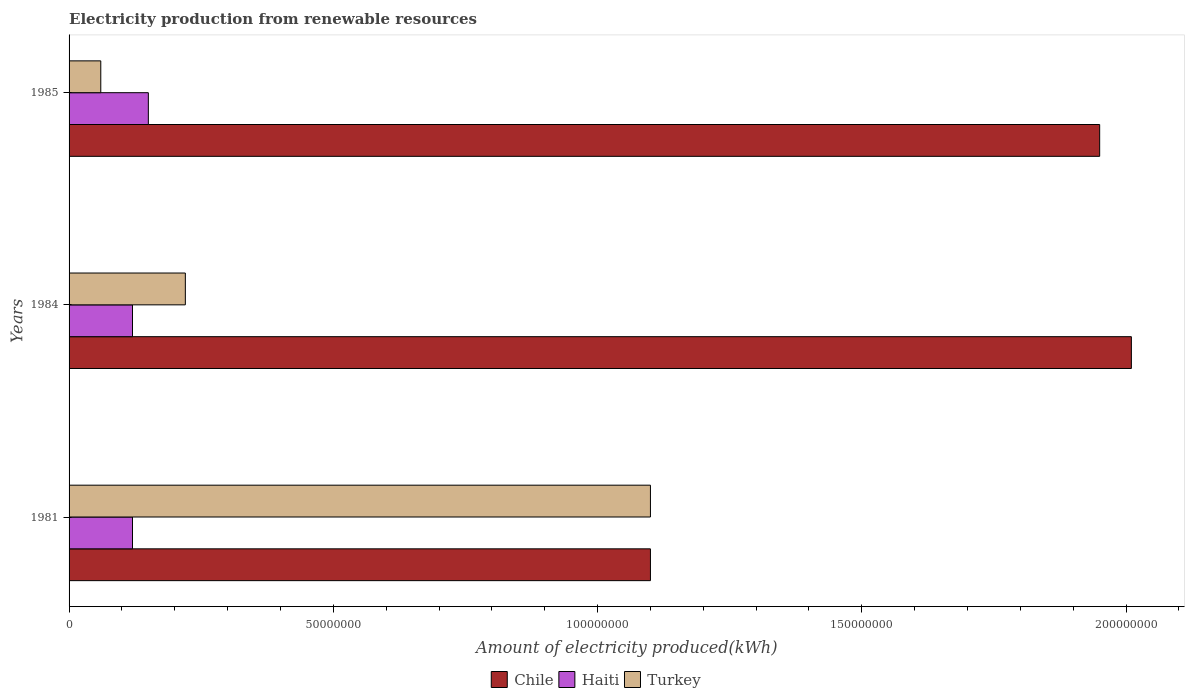Are the number of bars on each tick of the Y-axis equal?
Your answer should be very brief. Yes. How many bars are there on the 2nd tick from the bottom?
Your response must be concise. 3. In how many cases, is the number of bars for a given year not equal to the number of legend labels?
Keep it short and to the point. 0. What is the amount of electricity produced in Turkey in 1985?
Your response must be concise. 6.00e+06. Across all years, what is the maximum amount of electricity produced in Haiti?
Keep it short and to the point. 1.50e+07. Across all years, what is the minimum amount of electricity produced in Chile?
Provide a short and direct response. 1.10e+08. In which year was the amount of electricity produced in Haiti minimum?
Your response must be concise. 1981. What is the total amount of electricity produced in Haiti in the graph?
Your response must be concise. 3.90e+07. What is the difference between the amount of electricity produced in Haiti in 1981 and the amount of electricity produced in Turkey in 1985?
Your answer should be very brief. 6.00e+06. What is the average amount of electricity produced in Haiti per year?
Your answer should be very brief. 1.30e+07. In the year 1981, what is the difference between the amount of electricity produced in Haiti and amount of electricity produced in Chile?
Give a very brief answer. -9.80e+07. In how many years, is the amount of electricity produced in Chile greater than 20000000 kWh?
Provide a short and direct response. 3. What is the ratio of the amount of electricity produced in Turkey in 1984 to that in 1985?
Your answer should be compact. 3.67. What is the difference between the highest and the lowest amount of electricity produced in Haiti?
Your answer should be very brief. 3.00e+06. In how many years, is the amount of electricity produced in Chile greater than the average amount of electricity produced in Chile taken over all years?
Provide a short and direct response. 2. Is the sum of the amount of electricity produced in Haiti in 1981 and 1984 greater than the maximum amount of electricity produced in Chile across all years?
Ensure brevity in your answer.  No. What does the 2nd bar from the top in 1981 represents?
Offer a terse response. Haiti. What does the 2nd bar from the bottom in 1981 represents?
Offer a very short reply. Haiti. Is it the case that in every year, the sum of the amount of electricity produced in Turkey and amount of electricity produced in Chile is greater than the amount of electricity produced in Haiti?
Provide a succinct answer. Yes. How many bars are there?
Your answer should be compact. 9. What is the difference between two consecutive major ticks on the X-axis?
Your response must be concise. 5.00e+07. Does the graph contain any zero values?
Keep it short and to the point. No. Where does the legend appear in the graph?
Your answer should be compact. Bottom center. How many legend labels are there?
Give a very brief answer. 3. How are the legend labels stacked?
Provide a succinct answer. Horizontal. What is the title of the graph?
Make the answer very short. Electricity production from renewable resources. Does "Ukraine" appear as one of the legend labels in the graph?
Give a very brief answer. No. What is the label or title of the X-axis?
Provide a short and direct response. Amount of electricity produced(kWh). What is the Amount of electricity produced(kWh) of Chile in 1981?
Give a very brief answer. 1.10e+08. What is the Amount of electricity produced(kWh) of Turkey in 1981?
Offer a terse response. 1.10e+08. What is the Amount of electricity produced(kWh) in Chile in 1984?
Your answer should be very brief. 2.01e+08. What is the Amount of electricity produced(kWh) of Haiti in 1984?
Your answer should be very brief. 1.20e+07. What is the Amount of electricity produced(kWh) of Turkey in 1984?
Keep it short and to the point. 2.20e+07. What is the Amount of electricity produced(kWh) of Chile in 1985?
Make the answer very short. 1.95e+08. What is the Amount of electricity produced(kWh) in Haiti in 1985?
Offer a terse response. 1.50e+07. Across all years, what is the maximum Amount of electricity produced(kWh) of Chile?
Ensure brevity in your answer.  2.01e+08. Across all years, what is the maximum Amount of electricity produced(kWh) in Haiti?
Ensure brevity in your answer.  1.50e+07. Across all years, what is the maximum Amount of electricity produced(kWh) in Turkey?
Offer a terse response. 1.10e+08. Across all years, what is the minimum Amount of electricity produced(kWh) in Chile?
Your answer should be very brief. 1.10e+08. Across all years, what is the minimum Amount of electricity produced(kWh) of Turkey?
Provide a succinct answer. 6.00e+06. What is the total Amount of electricity produced(kWh) in Chile in the graph?
Your answer should be very brief. 5.06e+08. What is the total Amount of electricity produced(kWh) of Haiti in the graph?
Ensure brevity in your answer.  3.90e+07. What is the total Amount of electricity produced(kWh) in Turkey in the graph?
Ensure brevity in your answer.  1.38e+08. What is the difference between the Amount of electricity produced(kWh) in Chile in 1981 and that in 1984?
Your response must be concise. -9.10e+07. What is the difference between the Amount of electricity produced(kWh) of Haiti in 1981 and that in 1984?
Your answer should be compact. 0. What is the difference between the Amount of electricity produced(kWh) of Turkey in 1981 and that in 1984?
Your response must be concise. 8.80e+07. What is the difference between the Amount of electricity produced(kWh) in Chile in 1981 and that in 1985?
Offer a very short reply. -8.50e+07. What is the difference between the Amount of electricity produced(kWh) of Turkey in 1981 and that in 1985?
Offer a very short reply. 1.04e+08. What is the difference between the Amount of electricity produced(kWh) of Turkey in 1984 and that in 1985?
Your answer should be very brief. 1.60e+07. What is the difference between the Amount of electricity produced(kWh) of Chile in 1981 and the Amount of electricity produced(kWh) of Haiti in 1984?
Provide a short and direct response. 9.80e+07. What is the difference between the Amount of electricity produced(kWh) of Chile in 1981 and the Amount of electricity produced(kWh) of Turkey in 1984?
Ensure brevity in your answer.  8.80e+07. What is the difference between the Amount of electricity produced(kWh) in Haiti in 1981 and the Amount of electricity produced(kWh) in Turkey in 1984?
Your answer should be very brief. -1.00e+07. What is the difference between the Amount of electricity produced(kWh) in Chile in 1981 and the Amount of electricity produced(kWh) in Haiti in 1985?
Your answer should be compact. 9.50e+07. What is the difference between the Amount of electricity produced(kWh) in Chile in 1981 and the Amount of electricity produced(kWh) in Turkey in 1985?
Your answer should be very brief. 1.04e+08. What is the difference between the Amount of electricity produced(kWh) in Chile in 1984 and the Amount of electricity produced(kWh) in Haiti in 1985?
Your answer should be compact. 1.86e+08. What is the difference between the Amount of electricity produced(kWh) of Chile in 1984 and the Amount of electricity produced(kWh) of Turkey in 1985?
Make the answer very short. 1.95e+08. What is the difference between the Amount of electricity produced(kWh) of Haiti in 1984 and the Amount of electricity produced(kWh) of Turkey in 1985?
Your answer should be compact. 6.00e+06. What is the average Amount of electricity produced(kWh) of Chile per year?
Keep it short and to the point. 1.69e+08. What is the average Amount of electricity produced(kWh) in Haiti per year?
Ensure brevity in your answer.  1.30e+07. What is the average Amount of electricity produced(kWh) of Turkey per year?
Offer a terse response. 4.60e+07. In the year 1981, what is the difference between the Amount of electricity produced(kWh) of Chile and Amount of electricity produced(kWh) of Haiti?
Provide a succinct answer. 9.80e+07. In the year 1981, what is the difference between the Amount of electricity produced(kWh) in Chile and Amount of electricity produced(kWh) in Turkey?
Your answer should be very brief. 0. In the year 1981, what is the difference between the Amount of electricity produced(kWh) in Haiti and Amount of electricity produced(kWh) in Turkey?
Provide a short and direct response. -9.80e+07. In the year 1984, what is the difference between the Amount of electricity produced(kWh) of Chile and Amount of electricity produced(kWh) of Haiti?
Ensure brevity in your answer.  1.89e+08. In the year 1984, what is the difference between the Amount of electricity produced(kWh) of Chile and Amount of electricity produced(kWh) of Turkey?
Make the answer very short. 1.79e+08. In the year 1984, what is the difference between the Amount of electricity produced(kWh) in Haiti and Amount of electricity produced(kWh) in Turkey?
Give a very brief answer. -1.00e+07. In the year 1985, what is the difference between the Amount of electricity produced(kWh) in Chile and Amount of electricity produced(kWh) in Haiti?
Offer a very short reply. 1.80e+08. In the year 1985, what is the difference between the Amount of electricity produced(kWh) in Chile and Amount of electricity produced(kWh) in Turkey?
Keep it short and to the point. 1.89e+08. In the year 1985, what is the difference between the Amount of electricity produced(kWh) of Haiti and Amount of electricity produced(kWh) of Turkey?
Ensure brevity in your answer.  9.00e+06. What is the ratio of the Amount of electricity produced(kWh) in Chile in 1981 to that in 1984?
Keep it short and to the point. 0.55. What is the ratio of the Amount of electricity produced(kWh) of Chile in 1981 to that in 1985?
Provide a succinct answer. 0.56. What is the ratio of the Amount of electricity produced(kWh) of Haiti in 1981 to that in 1985?
Keep it short and to the point. 0.8. What is the ratio of the Amount of electricity produced(kWh) of Turkey in 1981 to that in 1985?
Ensure brevity in your answer.  18.33. What is the ratio of the Amount of electricity produced(kWh) of Chile in 1984 to that in 1985?
Keep it short and to the point. 1.03. What is the ratio of the Amount of electricity produced(kWh) of Haiti in 1984 to that in 1985?
Your response must be concise. 0.8. What is the ratio of the Amount of electricity produced(kWh) of Turkey in 1984 to that in 1985?
Provide a short and direct response. 3.67. What is the difference between the highest and the second highest Amount of electricity produced(kWh) of Chile?
Give a very brief answer. 6.00e+06. What is the difference between the highest and the second highest Amount of electricity produced(kWh) in Haiti?
Keep it short and to the point. 3.00e+06. What is the difference between the highest and the second highest Amount of electricity produced(kWh) of Turkey?
Make the answer very short. 8.80e+07. What is the difference between the highest and the lowest Amount of electricity produced(kWh) of Chile?
Keep it short and to the point. 9.10e+07. What is the difference between the highest and the lowest Amount of electricity produced(kWh) in Haiti?
Ensure brevity in your answer.  3.00e+06. What is the difference between the highest and the lowest Amount of electricity produced(kWh) of Turkey?
Your answer should be compact. 1.04e+08. 